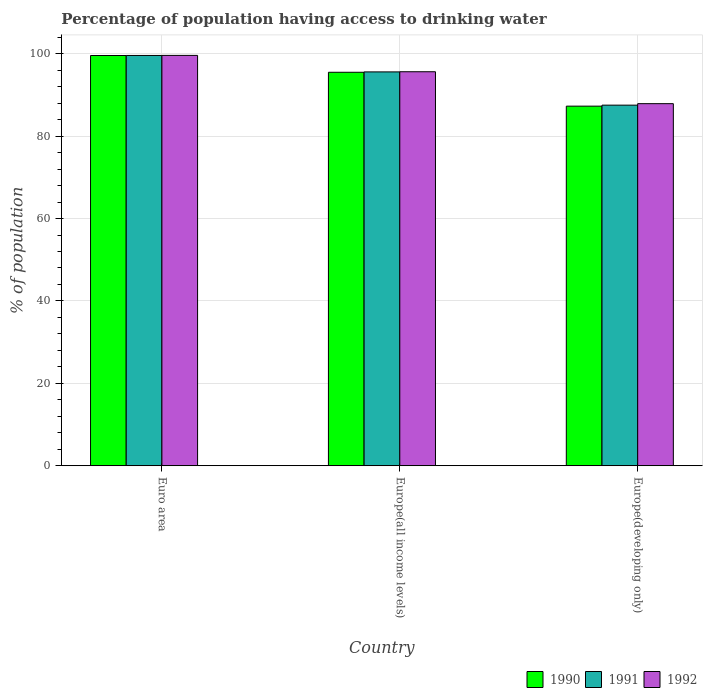How many different coloured bars are there?
Offer a terse response. 3. How many groups of bars are there?
Offer a very short reply. 3. How many bars are there on the 2nd tick from the right?
Keep it short and to the point. 3. What is the label of the 3rd group of bars from the left?
Provide a short and direct response. Europe(developing only). What is the percentage of population having access to drinking water in 1991 in Euro area?
Your answer should be compact. 99.58. Across all countries, what is the maximum percentage of population having access to drinking water in 1991?
Make the answer very short. 99.58. Across all countries, what is the minimum percentage of population having access to drinking water in 1991?
Give a very brief answer. 87.52. In which country was the percentage of population having access to drinking water in 1992 minimum?
Keep it short and to the point. Europe(developing only). What is the total percentage of population having access to drinking water in 1991 in the graph?
Provide a short and direct response. 282.69. What is the difference between the percentage of population having access to drinking water in 1992 in Euro area and that in Europe(all income levels)?
Your answer should be very brief. 3.97. What is the difference between the percentage of population having access to drinking water in 1992 in Europe(developing only) and the percentage of population having access to drinking water in 1990 in Europe(all income levels)?
Provide a short and direct response. -7.62. What is the average percentage of population having access to drinking water in 1990 per country?
Your answer should be very brief. 94.11. What is the difference between the percentage of population having access to drinking water of/in 1992 and percentage of population having access to drinking water of/in 1991 in Europe(all income levels)?
Your answer should be compact. 0.04. What is the ratio of the percentage of population having access to drinking water in 1991 in Europe(all income levels) to that in Europe(developing only)?
Your answer should be compact. 1.09. Is the percentage of population having access to drinking water in 1990 in Euro area less than that in Europe(developing only)?
Provide a succinct answer. No. What is the difference between the highest and the second highest percentage of population having access to drinking water in 1990?
Offer a terse response. 12.29. What is the difference between the highest and the lowest percentage of population having access to drinking water in 1991?
Offer a very short reply. 12.06. In how many countries, is the percentage of population having access to drinking water in 1990 greater than the average percentage of population having access to drinking water in 1990 taken over all countries?
Your answer should be very brief. 2. What does the 3rd bar from the right in Europe(all income levels) represents?
Make the answer very short. 1990. Is it the case that in every country, the sum of the percentage of population having access to drinking water in 1992 and percentage of population having access to drinking water in 1990 is greater than the percentage of population having access to drinking water in 1991?
Your answer should be compact. Yes. Are all the bars in the graph horizontal?
Give a very brief answer. No. What is the difference between two consecutive major ticks on the Y-axis?
Your answer should be compact. 20. Are the values on the major ticks of Y-axis written in scientific E-notation?
Provide a short and direct response. No. Does the graph contain any zero values?
Give a very brief answer. No. Where does the legend appear in the graph?
Keep it short and to the point. Bottom right. What is the title of the graph?
Give a very brief answer. Percentage of population having access to drinking water. Does "1984" appear as one of the legend labels in the graph?
Your answer should be very brief. No. What is the label or title of the Y-axis?
Ensure brevity in your answer.  % of population. What is the % of population in 1990 in Euro area?
Your response must be concise. 99.57. What is the % of population in 1991 in Euro area?
Your response must be concise. 99.58. What is the % of population in 1992 in Euro area?
Provide a succinct answer. 99.6. What is the % of population of 1990 in Europe(all income levels)?
Offer a very short reply. 95.5. What is the % of population in 1991 in Europe(all income levels)?
Keep it short and to the point. 95.59. What is the % of population in 1992 in Europe(all income levels)?
Keep it short and to the point. 95.63. What is the % of population in 1990 in Europe(developing only)?
Provide a short and direct response. 87.27. What is the % of population in 1991 in Europe(developing only)?
Make the answer very short. 87.52. What is the % of population of 1992 in Europe(developing only)?
Keep it short and to the point. 87.88. Across all countries, what is the maximum % of population in 1990?
Offer a terse response. 99.57. Across all countries, what is the maximum % of population of 1991?
Provide a succinct answer. 99.58. Across all countries, what is the maximum % of population of 1992?
Your answer should be very brief. 99.6. Across all countries, what is the minimum % of population of 1990?
Make the answer very short. 87.27. Across all countries, what is the minimum % of population of 1991?
Make the answer very short. 87.52. Across all countries, what is the minimum % of population of 1992?
Offer a terse response. 87.88. What is the total % of population in 1990 in the graph?
Give a very brief answer. 282.34. What is the total % of population in 1991 in the graph?
Provide a short and direct response. 282.69. What is the total % of population in 1992 in the graph?
Your response must be concise. 283.1. What is the difference between the % of population in 1990 in Euro area and that in Europe(all income levels)?
Keep it short and to the point. 4.07. What is the difference between the % of population in 1991 in Euro area and that in Europe(all income levels)?
Ensure brevity in your answer.  3.99. What is the difference between the % of population in 1992 in Euro area and that in Europe(all income levels)?
Ensure brevity in your answer.  3.97. What is the difference between the % of population in 1990 in Euro area and that in Europe(developing only)?
Ensure brevity in your answer.  12.29. What is the difference between the % of population of 1991 in Euro area and that in Europe(developing only)?
Offer a very short reply. 12.06. What is the difference between the % of population of 1992 in Euro area and that in Europe(developing only)?
Your response must be concise. 11.72. What is the difference between the % of population of 1990 in Europe(all income levels) and that in Europe(developing only)?
Make the answer very short. 8.22. What is the difference between the % of population in 1991 in Europe(all income levels) and that in Europe(developing only)?
Offer a terse response. 8.07. What is the difference between the % of population of 1992 in Europe(all income levels) and that in Europe(developing only)?
Provide a succinct answer. 7.75. What is the difference between the % of population of 1990 in Euro area and the % of population of 1991 in Europe(all income levels)?
Offer a very short reply. 3.98. What is the difference between the % of population of 1990 in Euro area and the % of population of 1992 in Europe(all income levels)?
Keep it short and to the point. 3.94. What is the difference between the % of population in 1991 in Euro area and the % of population in 1992 in Europe(all income levels)?
Keep it short and to the point. 3.95. What is the difference between the % of population of 1990 in Euro area and the % of population of 1991 in Europe(developing only)?
Make the answer very short. 12.05. What is the difference between the % of population of 1990 in Euro area and the % of population of 1992 in Europe(developing only)?
Your response must be concise. 11.69. What is the difference between the % of population of 1991 in Euro area and the % of population of 1992 in Europe(developing only)?
Your response must be concise. 11.7. What is the difference between the % of population in 1990 in Europe(all income levels) and the % of population in 1991 in Europe(developing only)?
Your answer should be compact. 7.98. What is the difference between the % of population of 1990 in Europe(all income levels) and the % of population of 1992 in Europe(developing only)?
Your answer should be compact. 7.62. What is the difference between the % of population in 1991 in Europe(all income levels) and the % of population in 1992 in Europe(developing only)?
Make the answer very short. 7.71. What is the average % of population in 1990 per country?
Offer a very short reply. 94.11. What is the average % of population of 1991 per country?
Your answer should be very brief. 94.23. What is the average % of population of 1992 per country?
Your answer should be compact. 94.37. What is the difference between the % of population in 1990 and % of population in 1991 in Euro area?
Your answer should be very brief. -0.01. What is the difference between the % of population of 1990 and % of population of 1992 in Euro area?
Make the answer very short. -0.03. What is the difference between the % of population of 1991 and % of population of 1992 in Euro area?
Keep it short and to the point. -0.02. What is the difference between the % of population in 1990 and % of population in 1991 in Europe(all income levels)?
Provide a short and direct response. -0.09. What is the difference between the % of population in 1990 and % of population in 1992 in Europe(all income levels)?
Your answer should be compact. -0.13. What is the difference between the % of population of 1991 and % of population of 1992 in Europe(all income levels)?
Your answer should be compact. -0.04. What is the difference between the % of population of 1990 and % of population of 1991 in Europe(developing only)?
Your answer should be very brief. -0.25. What is the difference between the % of population of 1990 and % of population of 1992 in Europe(developing only)?
Keep it short and to the point. -0.61. What is the difference between the % of population of 1991 and % of population of 1992 in Europe(developing only)?
Offer a terse response. -0.36. What is the ratio of the % of population of 1990 in Euro area to that in Europe(all income levels)?
Provide a short and direct response. 1.04. What is the ratio of the % of population in 1991 in Euro area to that in Europe(all income levels)?
Your response must be concise. 1.04. What is the ratio of the % of population in 1992 in Euro area to that in Europe(all income levels)?
Offer a very short reply. 1.04. What is the ratio of the % of population of 1990 in Euro area to that in Europe(developing only)?
Offer a very short reply. 1.14. What is the ratio of the % of population of 1991 in Euro area to that in Europe(developing only)?
Provide a short and direct response. 1.14. What is the ratio of the % of population in 1992 in Euro area to that in Europe(developing only)?
Your answer should be very brief. 1.13. What is the ratio of the % of population of 1990 in Europe(all income levels) to that in Europe(developing only)?
Provide a succinct answer. 1.09. What is the ratio of the % of population in 1991 in Europe(all income levels) to that in Europe(developing only)?
Give a very brief answer. 1.09. What is the ratio of the % of population of 1992 in Europe(all income levels) to that in Europe(developing only)?
Your answer should be very brief. 1.09. What is the difference between the highest and the second highest % of population in 1990?
Provide a succinct answer. 4.07. What is the difference between the highest and the second highest % of population in 1991?
Your answer should be compact. 3.99. What is the difference between the highest and the second highest % of population in 1992?
Ensure brevity in your answer.  3.97. What is the difference between the highest and the lowest % of population in 1990?
Provide a succinct answer. 12.29. What is the difference between the highest and the lowest % of population in 1991?
Your response must be concise. 12.06. What is the difference between the highest and the lowest % of population of 1992?
Offer a terse response. 11.72. 